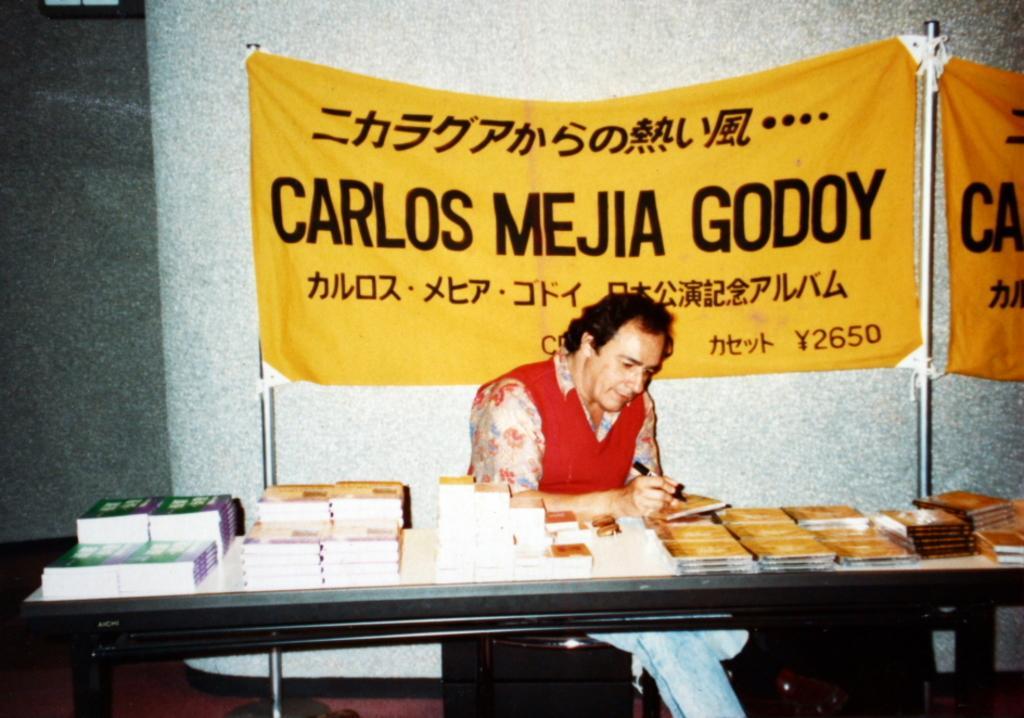How would you summarize this image in a sentence or two? In this picture we can see one person is sitting in front of the table on it so many books are placed, back side one banner is placed. 